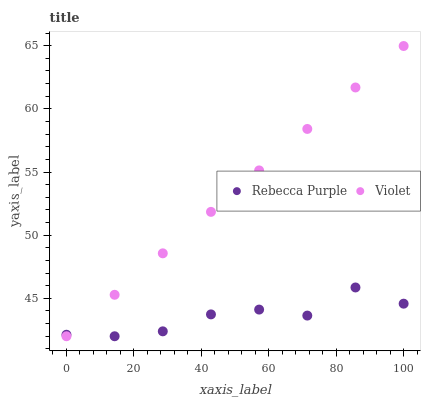Does Rebecca Purple have the minimum area under the curve?
Answer yes or no. Yes. Does Violet have the maximum area under the curve?
Answer yes or no. Yes. Does Violet have the minimum area under the curve?
Answer yes or no. No. Is Violet the smoothest?
Answer yes or no. Yes. Is Rebecca Purple the roughest?
Answer yes or no. Yes. Is Violet the roughest?
Answer yes or no. No. Does Rebecca Purple have the lowest value?
Answer yes or no. Yes. Does Violet have the highest value?
Answer yes or no. Yes. Does Violet intersect Rebecca Purple?
Answer yes or no. Yes. Is Violet less than Rebecca Purple?
Answer yes or no. No. Is Violet greater than Rebecca Purple?
Answer yes or no. No. 